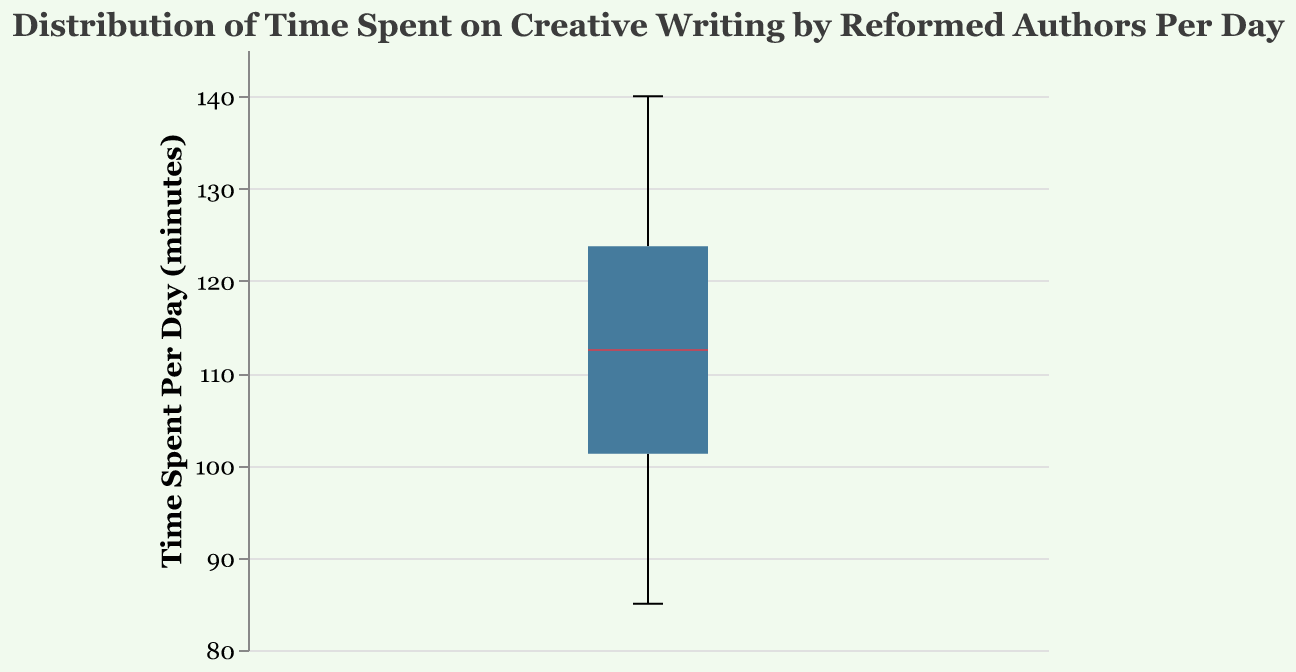What is the title of the figure? The title of the figure is prominently displayed at the top and is labeled "Distribution of Time Spent on Creative Writing by Reformed Authors Per Day".
Answer: Distribution of Time Spent on Creative Writing by Reformed Authors Per Day What is the unit of measurement on the y-axis? The y-axis measures time in minutes and is labeled "Time Spent Per Day (minutes)".
Answer: minutes What is the median time spent on creative writing per day? The median value is often represented by a line inside the box of the box plot. In this plot, the median time spent per day is around 110 minutes.
Answer: 110 minutes What is the minimum time recorded for creative writing per day? The minimum value can be observed as the bottom whisker of the box plot, which indicates the lowest data point. Here, it is around 85 minutes.
Answer: 85 minutes What is the maximum time recorded for creative writing per day? The maximum value can be observed as the top whisker of the box plot, which represents the highest data point. Here, it is around 140 minutes.
Answer: 140 minutes What can you infer about the interquartile range (IQR) of time spent on creative writing per day? The IQR is the range between the first quartile (Q1, the bottom of the box) and the third quartile (Q3, the top of the box). This measurement represents the middle 50% of the data. Here, the IQR spans approximately from 95 to 125 minutes.
Answer: 95 to 125 minutes How many authors are represented in the data? Each data point corresponds to an author’s record of time spent on creative writing per day. There are 10 authors in this dataset.
Answer: 10 Which author appears to have spent the most time on creative writing per day and how much? Jean Valjean is the author with the highest time spent on creative writing, represented by one of the whiskers reaching up to 140 minutes.
Answer: Jean Valjean, 140 minutes Does the notched part of the box plot suggest that the median values of any two groups of authors are significantly different? The notch represents a rough visual comparison of medians. If the notches of two boxes do not overlap, it suggests that the medians are significantly different at roughly the 95% confidence level. Here, the notches do not indicate any clear significant difference within this single distribution.
Answer: Not significantly different What is the outlier in this data set, if any? There are no outliers marked in this notched box plot as all data points fall within the whiskers' range (minimum and maximum of the data).
Answer: None 